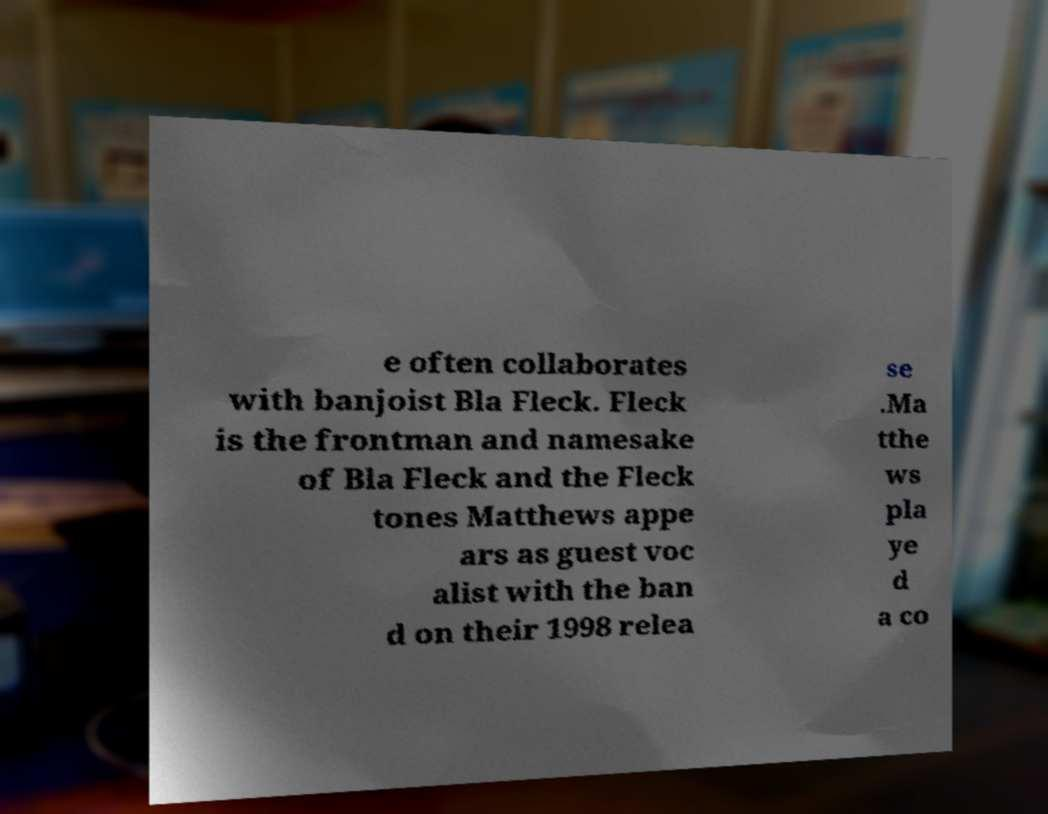Could you assist in decoding the text presented in this image and type it out clearly? e often collaborates with banjoist Bla Fleck. Fleck is the frontman and namesake of Bla Fleck and the Fleck tones Matthews appe ars as guest voc alist with the ban d on their 1998 relea se .Ma tthe ws pla ye d a co 